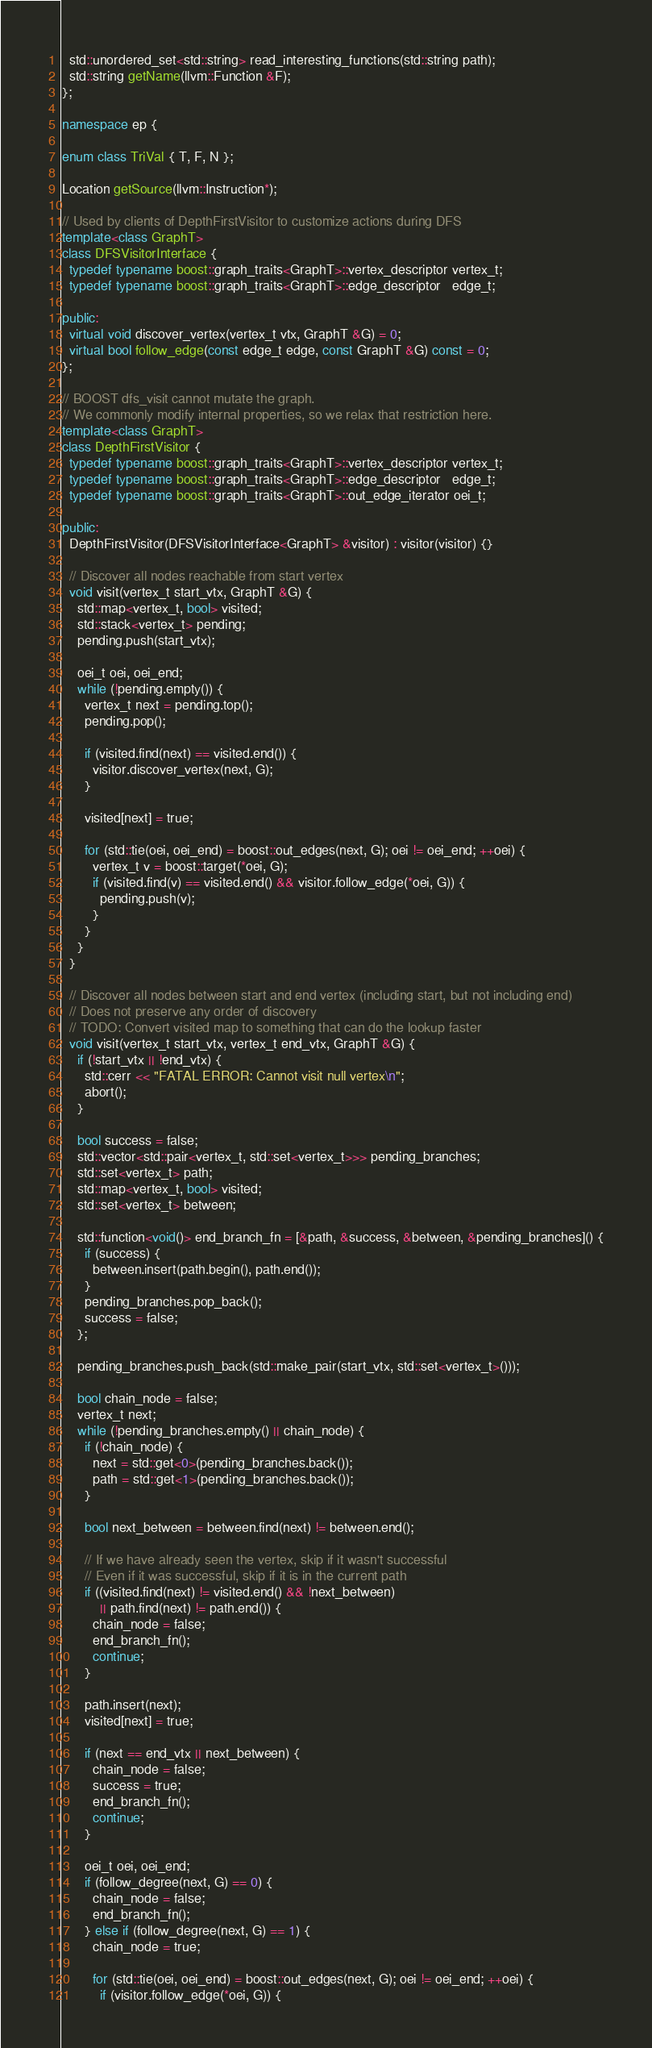<code> <loc_0><loc_0><loc_500><loc_500><_C++_>  std::unordered_set<std::string> read_interesting_functions(std::string path);
  std::string getName(llvm::Function &F);
};

namespace ep {

enum class TriVal { T, F, N };

Location getSource(llvm::Instruction*);

// Used by clients of DepthFirstVisitor to customize actions during DFS
template<class GraphT>
class DFSVisitorInterface {
  typedef typename boost::graph_traits<GraphT>::vertex_descriptor vertex_t;
  typedef typename boost::graph_traits<GraphT>::edge_descriptor   edge_t;

public:
  virtual void discover_vertex(vertex_t vtx, GraphT &G) = 0;
  virtual bool follow_edge(const edge_t edge, const GraphT &G) const = 0;
};

// BOOST dfs_visit cannot mutate the graph.
// We commonly modify internal properties, so we relax that restriction here.
template<class GraphT>
class DepthFirstVisitor {
  typedef typename boost::graph_traits<GraphT>::vertex_descriptor vertex_t;
  typedef typename boost::graph_traits<GraphT>::edge_descriptor   edge_t;
  typedef typename boost::graph_traits<GraphT>::out_edge_iterator oei_t;

public:
  DepthFirstVisitor(DFSVisitorInterface<GraphT> &visitor) : visitor(visitor) {}

  // Discover all nodes reachable from start vertex
  void visit(vertex_t start_vtx, GraphT &G) {
    std::map<vertex_t, bool> visited;
    std::stack<vertex_t> pending;
    pending.push(start_vtx);

    oei_t oei, oei_end;
    while (!pending.empty()) {
      vertex_t next = pending.top();
      pending.pop();

      if (visited.find(next) == visited.end()) {
        visitor.discover_vertex(next, G);
      }

      visited[next] = true;

      for (std::tie(oei, oei_end) = boost::out_edges(next, G); oei != oei_end; ++oei) {
        vertex_t v = boost::target(*oei, G);
        if (visited.find(v) == visited.end() && visitor.follow_edge(*oei, G)) {
          pending.push(v);
        }
      }
    }
  }

  // Discover all nodes between start and end vertex (including start, but not including end)
  // Does not preserve any order of discovery
  // TODO: Convert visited map to something that can do the lookup faster
  void visit(vertex_t start_vtx, vertex_t end_vtx, GraphT &G) {
    if (!start_vtx || !end_vtx) {
      std::cerr << "FATAL ERROR: Cannot visit null vertex\n";
      abort();
    }

    bool success = false;
    std::vector<std::pair<vertex_t, std::set<vertex_t>>> pending_branches;
    std::set<vertex_t> path;
    std::map<vertex_t, bool> visited;
    std::set<vertex_t> between;

    std::function<void()> end_branch_fn = [&path, &success, &between, &pending_branches]() {
      if (success) {
        between.insert(path.begin(), path.end());
      }
      pending_branches.pop_back();
      success = false;
    };

    pending_branches.push_back(std::make_pair(start_vtx, std::set<vertex_t>()));
    
    bool chain_node = false;
    vertex_t next;
    while (!pending_branches.empty() || chain_node) {     
      if (!chain_node) {
        next = std::get<0>(pending_branches.back());
        path = std::get<1>(pending_branches.back());
      }

      bool next_between = between.find(next) != between.end();

      // If we have already seen the vertex, skip if it wasn't successful
      // Even if it was successful, skip if it is in the current path
      if ((visited.find(next) != visited.end() && !next_between) 
          || path.find(next) != path.end()) {
        chain_node = false;
        end_branch_fn();
        continue;
      }

      path.insert(next);
      visited[next] = true;

      if (next == end_vtx || next_between) {
        chain_node = false;
        success = true;
        end_branch_fn();
        continue;
      }

      oei_t oei, oei_end;
      if (follow_degree(next, G) == 0) {
        chain_node = false;
        end_branch_fn();
      } else if (follow_degree(next, G) == 1) {
        chain_node = true;
  
        for (std::tie(oei, oei_end) = boost::out_edges(next, G); oei != oei_end; ++oei) {
          if (visitor.follow_edge(*oei, G)) {</code> 